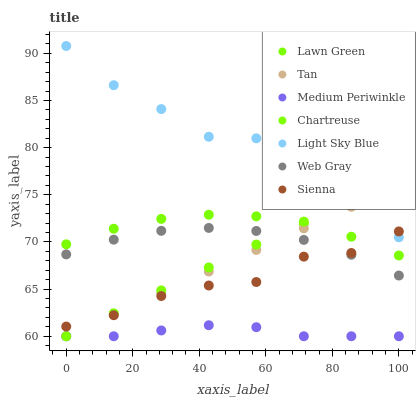Does Medium Periwinkle have the minimum area under the curve?
Answer yes or no. Yes. Does Light Sky Blue have the maximum area under the curve?
Answer yes or no. Yes. Does Web Gray have the minimum area under the curve?
Answer yes or no. No. Does Web Gray have the maximum area under the curve?
Answer yes or no. No. Is Tan the smoothest?
Answer yes or no. Yes. Is Light Sky Blue the roughest?
Answer yes or no. Yes. Is Web Gray the smoothest?
Answer yes or no. No. Is Web Gray the roughest?
Answer yes or no. No. Does Medium Periwinkle have the lowest value?
Answer yes or no. Yes. Does Web Gray have the lowest value?
Answer yes or no. No. Does Light Sky Blue have the highest value?
Answer yes or no. Yes. Does Web Gray have the highest value?
Answer yes or no. No. Is Medium Periwinkle less than Web Gray?
Answer yes or no. Yes. Is Light Sky Blue greater than Lawn Green?
Answer yes or no. Yes. Does Tan intersect Light Sky Blue?
Answer yes or no. Yes. Is Tan less than Light Sky Blue?
Answer yes or no. No. Is Tan greater than Light Sky Blue?
Answer yes or no. No. Does Medium Periwinkle intersect Web Gray?
Answer yes or no. No. 